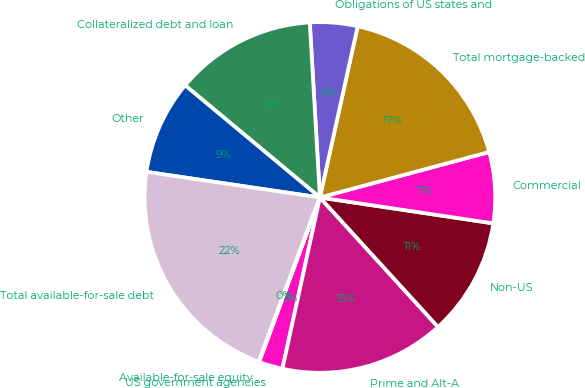<chart> <loc_0><loc_0><loc_500><loc_500><pie_chart><fcel>US government agencies<fcel>Prime and Alt-A<fcel>Non-US<fcel>Commercial<fcel>Total mortgage-backed<fcel>Obligations of US states and<fcel>Collateralized debt and loan<fcel>Other<fcel>Total available-for-sale debt<fcel>Available-for-sale equity<nl><fcel>2.21%<fcel>15.2%<fcel>10.87%<fcel>6.54%<fcel>17.37%<fcel>4.38%<fcel>13.04%<fcel>8.71%<fcel>21.65%<fcel>0.05%<nl></chart> 